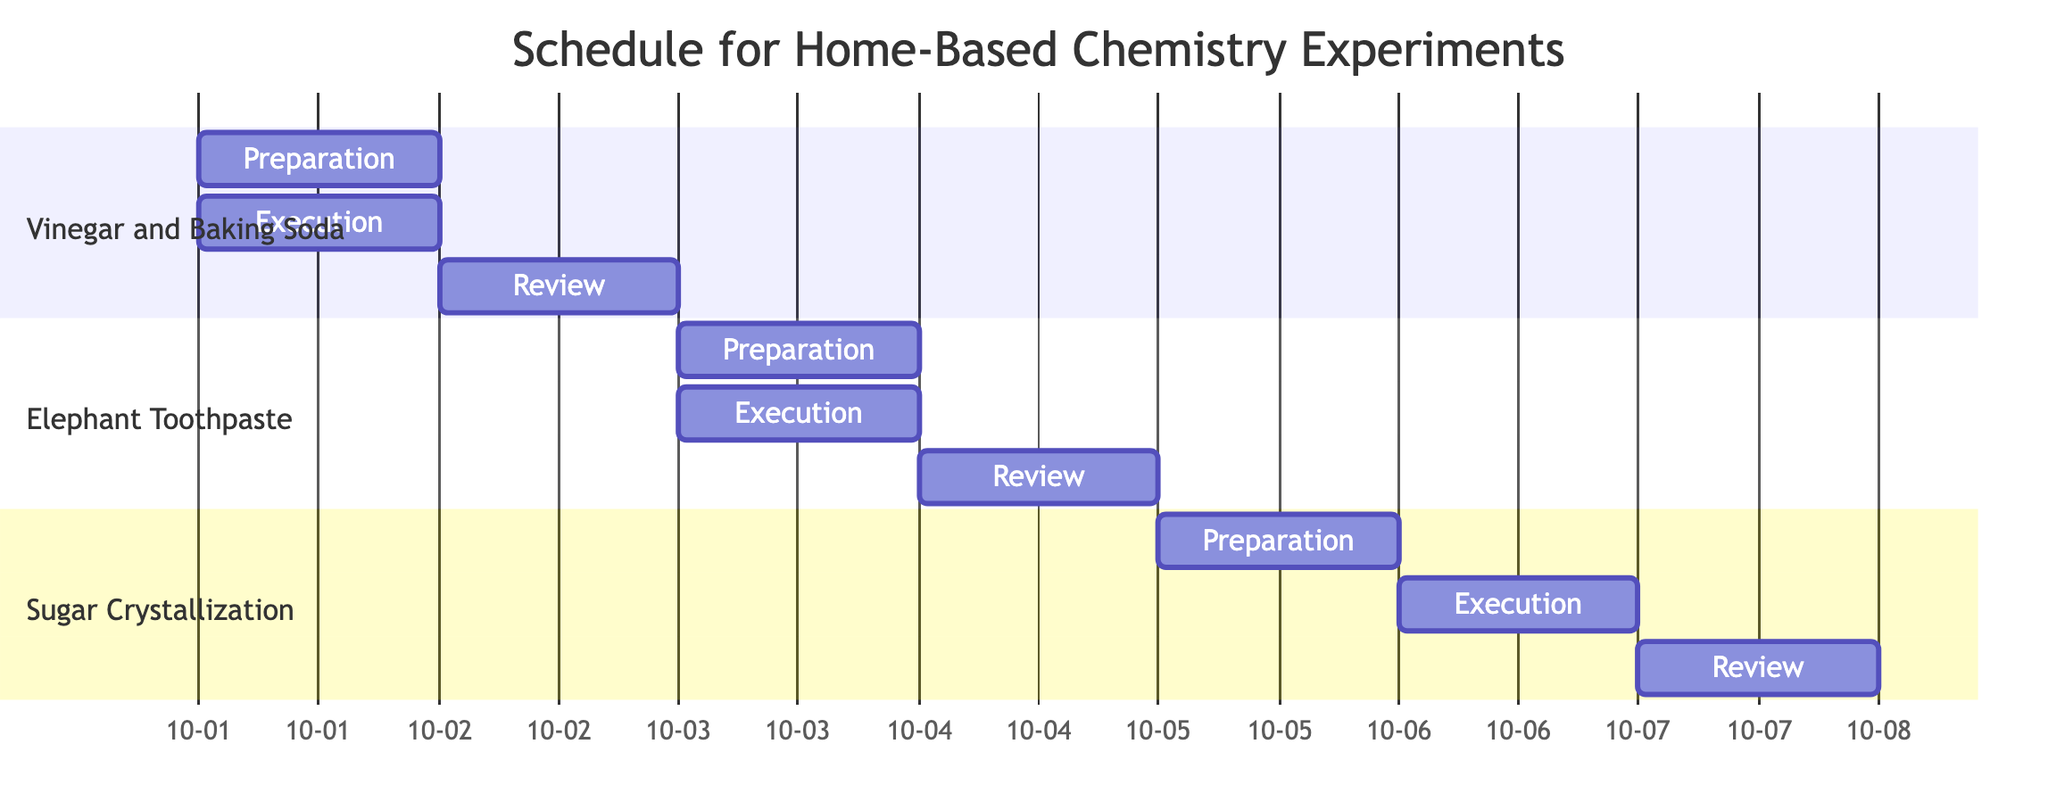What are the tasks in the preparation phase for the "Vinegar and Baking Soda Reaction"? In the Gantt chart, locate the section labeled "Vinegar and Baking Soda". Under the "Preparation" task, the tasks listed are "Gather materials (vinegar, baking soda, container, measuring cups)" and "Set up workspace".
Answer: Gather materials (vinegar, baking soda, container, measuring cups), Set up workspace On what date does the execution phase of the "Elephant Toothpaste Experiment" occur? Referring to the "Elephant Toothpaste" section in the Gantt chart, the "Execution" task has a start date of "2023-10-03" and an end date of "2023-10-03", indicating that this phase takes place on that date.
Answer: 2023-10-03 Which experiment has its review phase scheduled immediately after the execution phase? To determine this, examine each section of the Gantt chart. The "Vinegar and Baking Soda Reaction" has its review phase on "2023-10-02" immediately following its execution on "2023-10-01". Each subsequent experiment has a gap, implying only the first one meets this condition.
Answer: Vinegar and Baking Soda Reaction How many days are allocated for each preparation phase in the schedule? Each "Preparation" task in the Gantt chart is assigned one day, as denoted by the "1d" following each preparation date under the respective experiment sections.
Answer: 1 Which experiment occurs last in the schedule? By comparing the end dates of all experiments in the Gantt chart, the final end date belongs to the "Chemical Crystallization of Sugar" review phase on "2023-10-07", indicating this is the last scheduled experiment.
Answer: Chemical Crystallization of Sugar What is the total number of unique experiments shown in the Gantt Chart? The "experiments" data shows three distinct experiments, each represented in its own section of the Gantt chart. This is verified by the separate labeled sections in the diagram.
Answer: 3 Which phase involves discussing safety and chemical reactions? The "Review" phase of the "Vinegar and Baking Soda Reaction" section includes a specific task titled "Discuss safety and chemical reactions". This can be found in the listed tasks for that review section.
Answer: Review What are the tasks in the execution phase for the "Chemical Crystallization of Sugar"? In the Gantt chart, refer to the "Chemical Crystallization of Sugar" section where the execution tasks are "Dissolve sugar in water by heating" and "Allow solution to cool and crystallize".
Answer: Dissolve sugar in water by heating, Allow solution to cool and crystallize How many days are set for the review phase of the "Elephant Toothpaste Experiment"? The "Review" task for the "Elephant Toothpaste Experiment" is indicated as lasting for one day, similar to other phases, as shown in the Gantt chart with the "1d" notation.
Answer: 1 